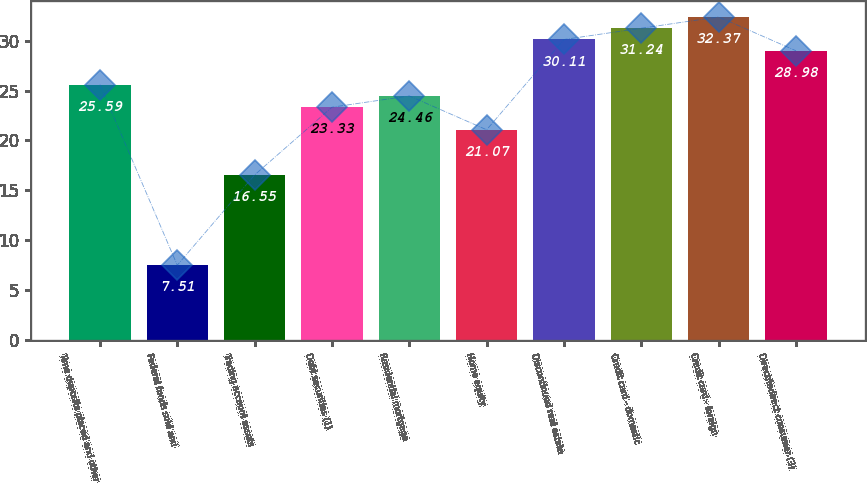<chart> <loc_0><loc_0><loc_500><loc_500><bar_chart><fcel>Time deposits placed and other<fcel>Federal funds sold and<fcel>Trading account assets<fcel>Debt securities (1)<fcel>Residential mortgage<fcel>Home equity<fcel>Discontinued real estate<fcel>Credit card - domestic<fcel>Credit card - foreign<fcel>Direct/Indirect consumer (3)<nl><fcel>25.59<fcel>7.51<fcel>16.55<fcel>23.33<fcel>24.46<fcel>21.07<fcel>30.11<fcel>31.24<fcel>32.37<fcel>28.98<nl></chart> 